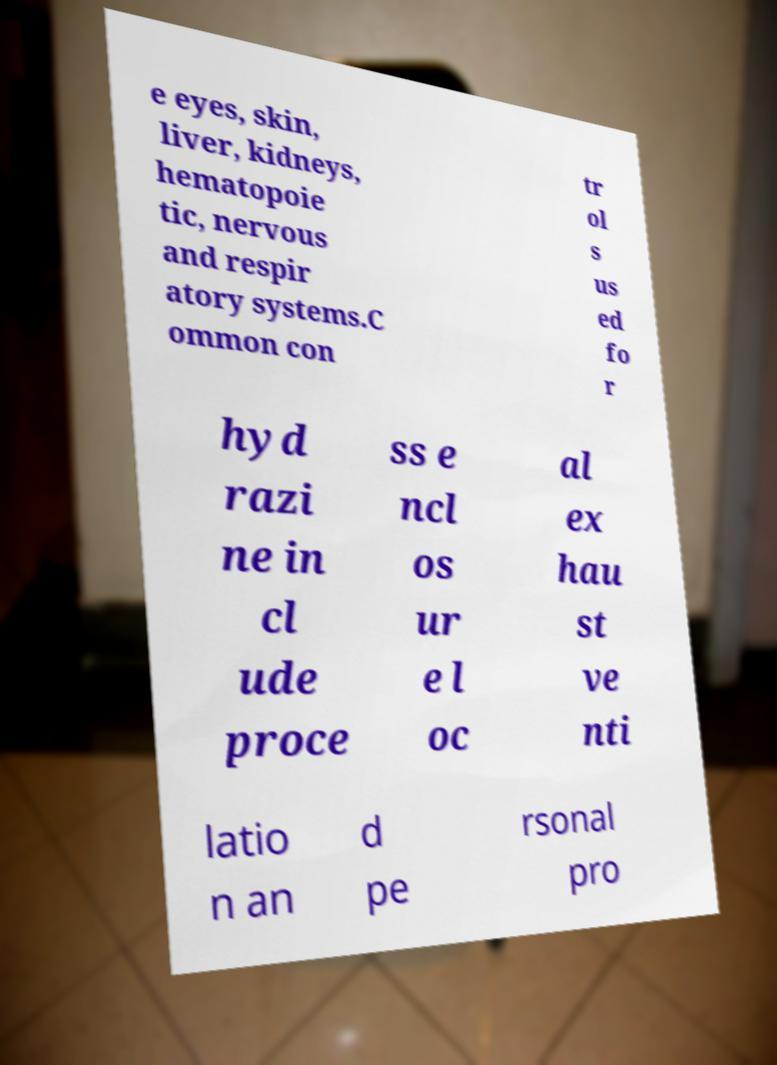For documentation purposes, I need the text within this image transcribed. Could you provide that? e eyes, skin, liver, kidneys, hematopoie tic, nervous and respir atory systems.C ommon con tr ol s us ed fo r hyd razi ne in cl ude proce ss e ncl os ur e l oc al ex hau st ve nti latio n an d pe rsonal pro 